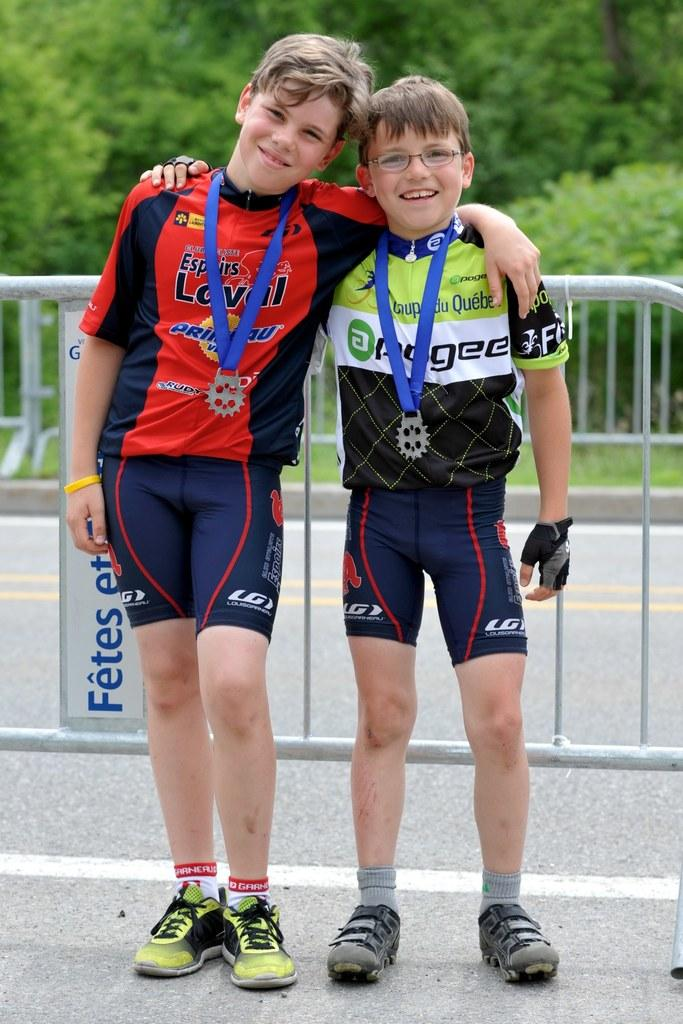<image>
Summarize the visual content of the image. 2 boys wearing blue LG shorts with their arms around each other and each has a medal 